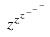<formula> <loc_0><loc_0><loc_500><loc_500>z ^ { z ^ { z ^ { - ^ { - ^ { - } } } } }</formula> 